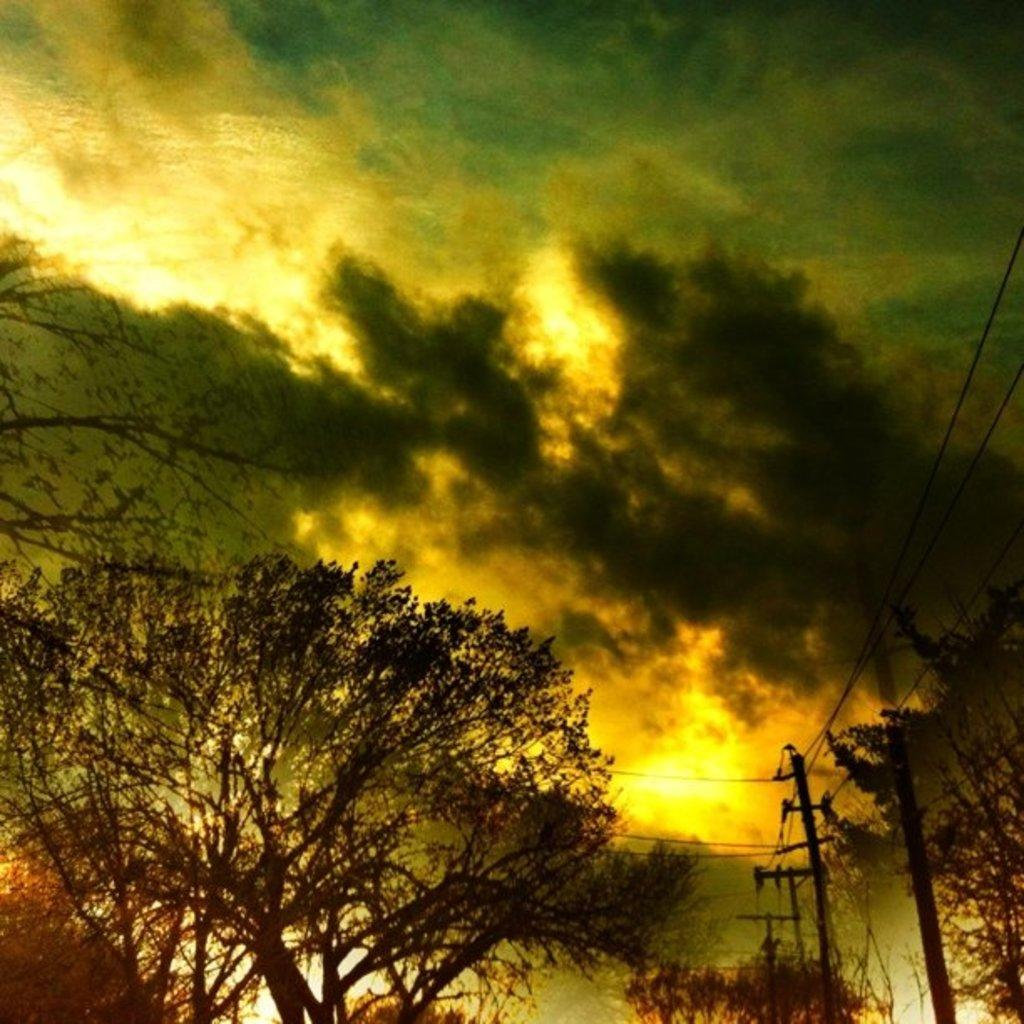What is the main feature of the image? The main feature of the image is the many trees. What structures can be seen to the right of the image? There are current poles to the right of the image. What are the current poles connected to? There are wires connected to the current poles. What can be seen in the back of the image? There are clouds and the sky visible in the back of the image. Where is the bucket located in the image? There is no bucket present in the image. Can you see any caves in the image? There are no caves visible in the image; it primarily features trees, current poles, wires, clouds, and the sky. 